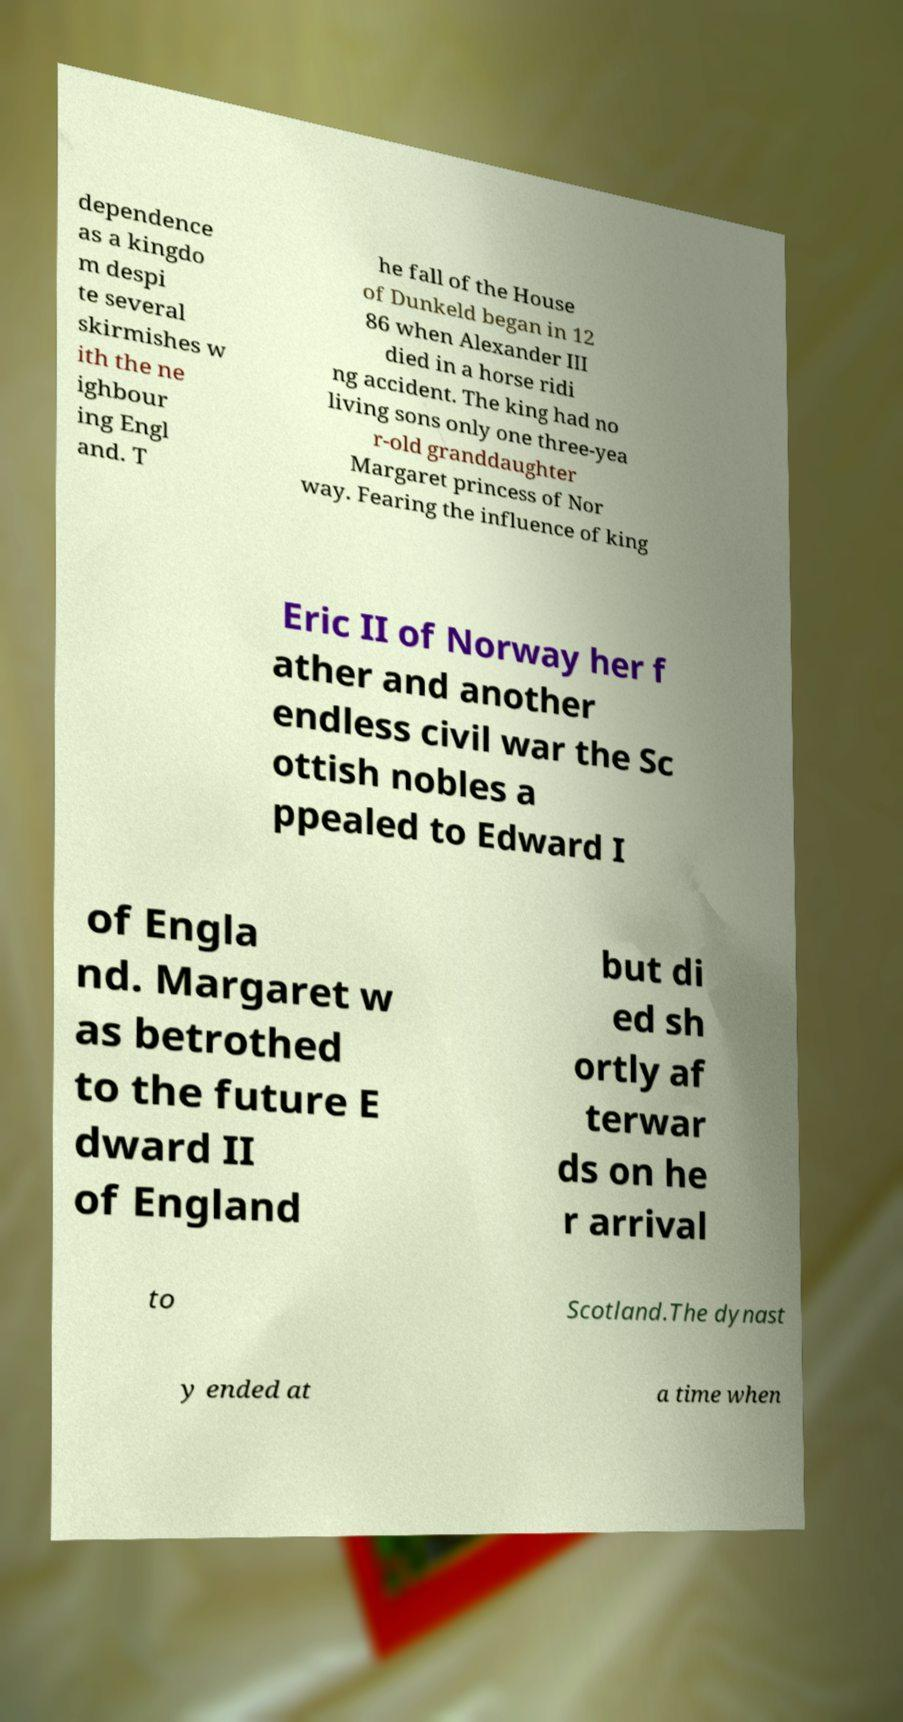Could you assist in decoding the text presented in this image and type it out clearly? dependence as a kingdo m despi te several skirmishes w ith the ne ighbour ing Engl and. T he fall of the House of Dunkeld began in 12 86 when Alexander III died in a horse ridi ng accident. The king had no living sons only one three-yea r-old granddaughter Margaret princess of Nor way. Fearing the influence of king Eric II of Norway her f ather and another endless civil war the Sc ottish nobles a ppealed to Edward I of Engla nd. Margaret w as betrothed to the future E dward II of England but di ed sh ortly af terwar ds on he r arrival to Scotland.The dynast y ended at a time when 